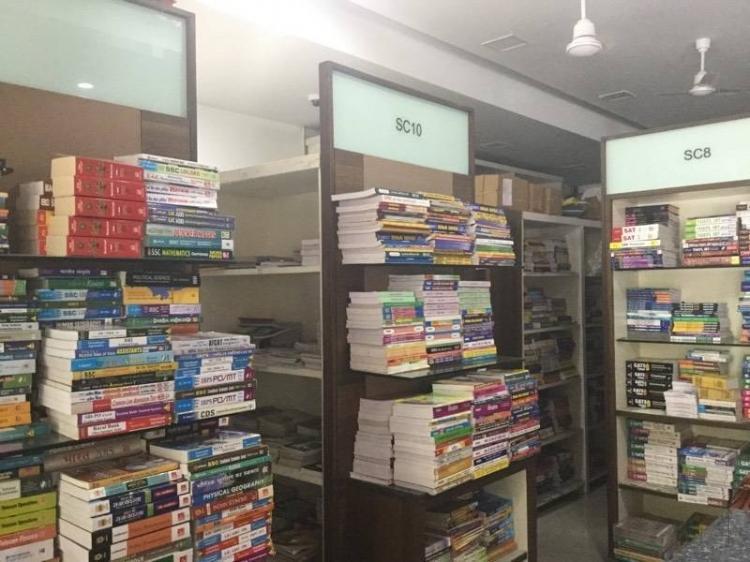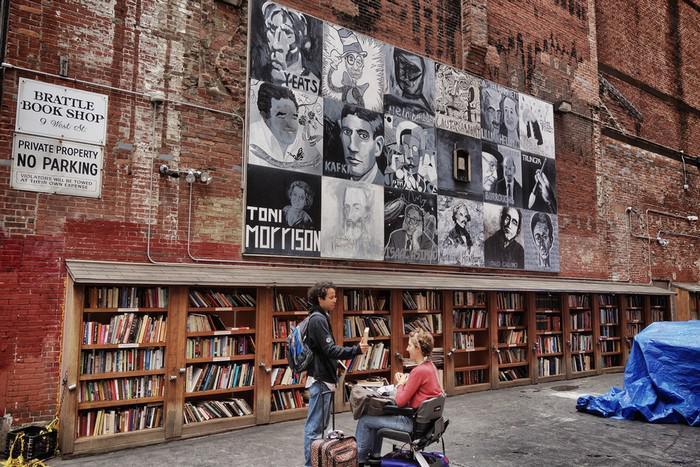The first image is the image on the left, the second image is the image on the right. Assess this claim about the two images: "At least one image shows a person standing in front of a counter and at least one person in a blue shirt behind a counter, with shelves full of books behind that person.". Correct or not? Answer yes or no. No. The first image is the image on the left, the second image is the image on the right. Assess this claim about the two images: "A single person is standing out side the book shop in the image on the left.". Correct or not? Answer yes or no. No. 